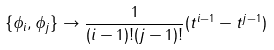Convert formula to latex. <formula><loc_0><loc_0><loc_500><loc_500>\{ \phi _ { i } , \phi _ { j } \} \rightarrow \frac { 1 } { ( i - 1 ) ! ( j - 1 ) ! } ( t ^ { i - 1 } - t ^ { j - 1 } )</formula> 